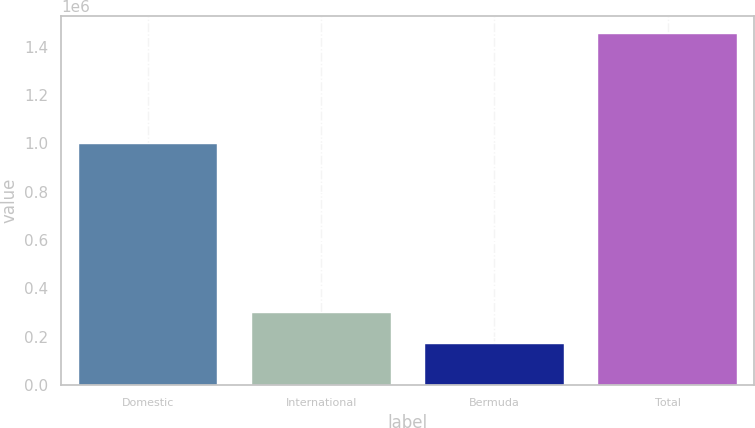Convert chart to OTSL. <chart><loc_0><loc_0><loc_500><loc_500><bar_chart><fcel>Domestic<fcel>International<fcel>Bermuda<fcel>Total<nl><fcel>998755<fcel>296491<fcel>167743<fcel>1.45522e+06<nl></chart> 